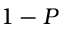<formula> <loc_0><loc_0><loc_500><loc_500>1 - P</formula> 